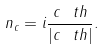Convert formula to latex. <formula><loc_0><loc_0><loc_500><loc_500>n _ { c } = i \frac { c _ { \ } t h } { | c _ { \ } t h | } .</formula> 